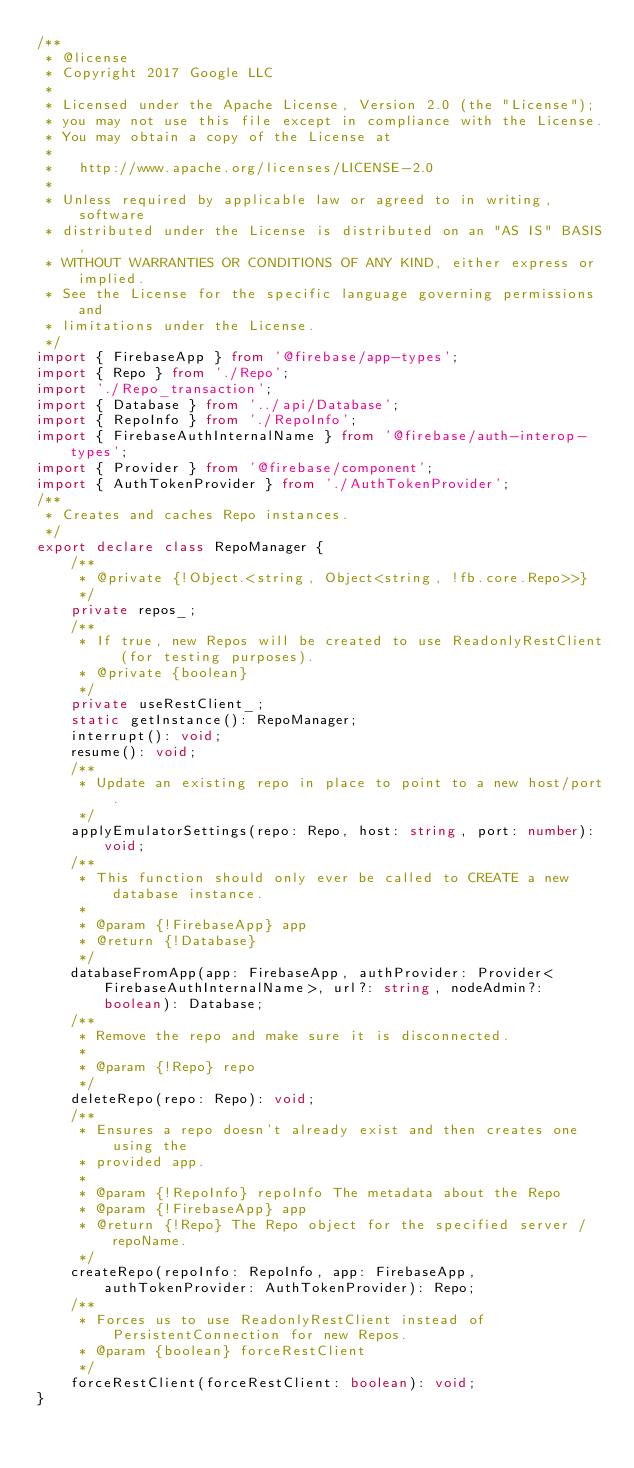Convert code to text. <code><loc_0><loc_0><loc_500><loc_500><_TypeScript_>/**
 * @license
 * Copyright 2017 Google LLC
 *
 * Licensed under the Apache License, Version 2.0 (the "License");
 * you may not use this file except in compliance with the License.
 * You may obtain a copy of the License at
 *
 *   http://www.apache.org/licenses/LICENSE-2.0
 *
 * Unless required by applicable law or agreed to in writing, software
 * distributed under the License is distributed on an "AS IS" BASIS,
 * WITHOUT WARRANTIES OR CONDITIONS OF ANY KIND, either express or implied.
 * See the License for the specific language governing permissions and
 * limitations under the License.
 */
import { FirebaseApp } from '@firebase/app-types';
import { Repo } from './Repo';
import './Repo_transaction';
import { Database } from '../api/Database';
import { RepoInfo } from './RepoInfo';
import { FirebaseAuthInternalName } from '@firebase/auth-interop-types';
import { Provider } from '@firebase/component';
import { AuthTokenProvider } from './AuthTokenProvider';
/**
 * Creates and caches Repo instances.
 */
export declare class RepoManager {
    /**
     * @private {!Object.<string, Object<string, !fb.core.Repo>>}
     */
    private repos_;
    /**
     * If true, new Repos will be created to use ReadonlyRestClient (for testing purposes).
     * @private {boolean}
     */
    private useRestClient_;
    static getInstance(): RepoManager;
    interrupt(): void;
    resume(): void;
    /**
     * Update an existing repo in place to point to a new host/port.
     */
    applyEmulatorSettings(repo: Repo, host: string, port: number): void;
    /**
     * This function should only ever be called to CREATE a new database instance.
     *
     * @param {!FirebaseApp} app
     * @return {!Database}
     */
    databaseFromApp(app: FirebaseApp, authProvider: Provider<FirebaseAuthInternalName>, url?: string, nodeAdmin?: boolean): Database;
    /**
     * Remove the repo and make sure it is disconnected.
     *
     * @param {!Repo} repo
     */
    deleteRepo(repo: Repo): void;
    /**
     * Ensures a repo doesn't already exist and then creates one using the
     * provided app.
     *
     * @param {!RepoInfo} repoInfo The metadata about the Repo
     * @param {!FirebaseApp} app
     * @return {!Repo} The Repo object for the specified server / repoName.
     */
    createRepo(repoInfo: RepoInfo, app: FirebaseApp, authTokenProvider: AuthTokenProvider): Repo;
    /**
     * Forces us to use ReadonlyRestClient instead of PersistentConnection for new Repos.
     * @param {boolean} forceRestClient
     */
    forceRestClient(forceRestClient: boolean): void;
}
</code> 